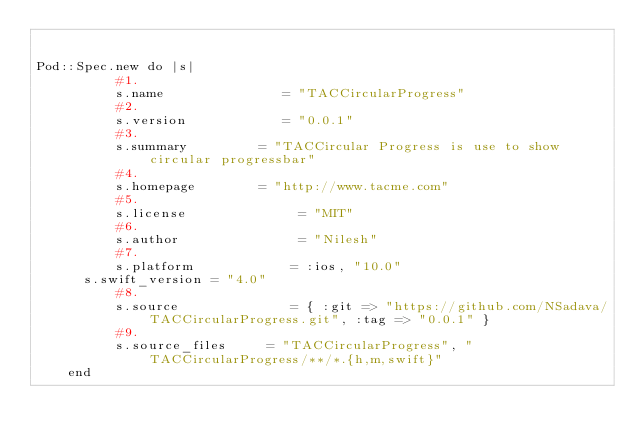<code> <loc_0><loc_0><loc_500><loc_500><_Ruby_>

Pod::Spec.new do |s|
          #1.
          s.name               = "TACCircularProgress"
          #2.
          s.version            = "0.0.1"
          #3.  
          s.summary         = "TACCircular Progress is use to show circular progressbar"
          #4.
          s.homepage        = "http://www.tacme.com"
          #5.
          s.license              = "MIT"
          #6.
          s.author               = "Nilesh"
          #7.
          s.platform            = :ios, "10.0"
	  s.swift_version = "4.0"
          #8.
          s.source              = { :git => "https://github.com/NSadava/TACCircularProgress.git", :tag => "0.0.1" }
          #9.
          s.source_files     = "TACCircularProgress", "TACCircularProgress/**/*.{h,m,swift}"
    end</code> 